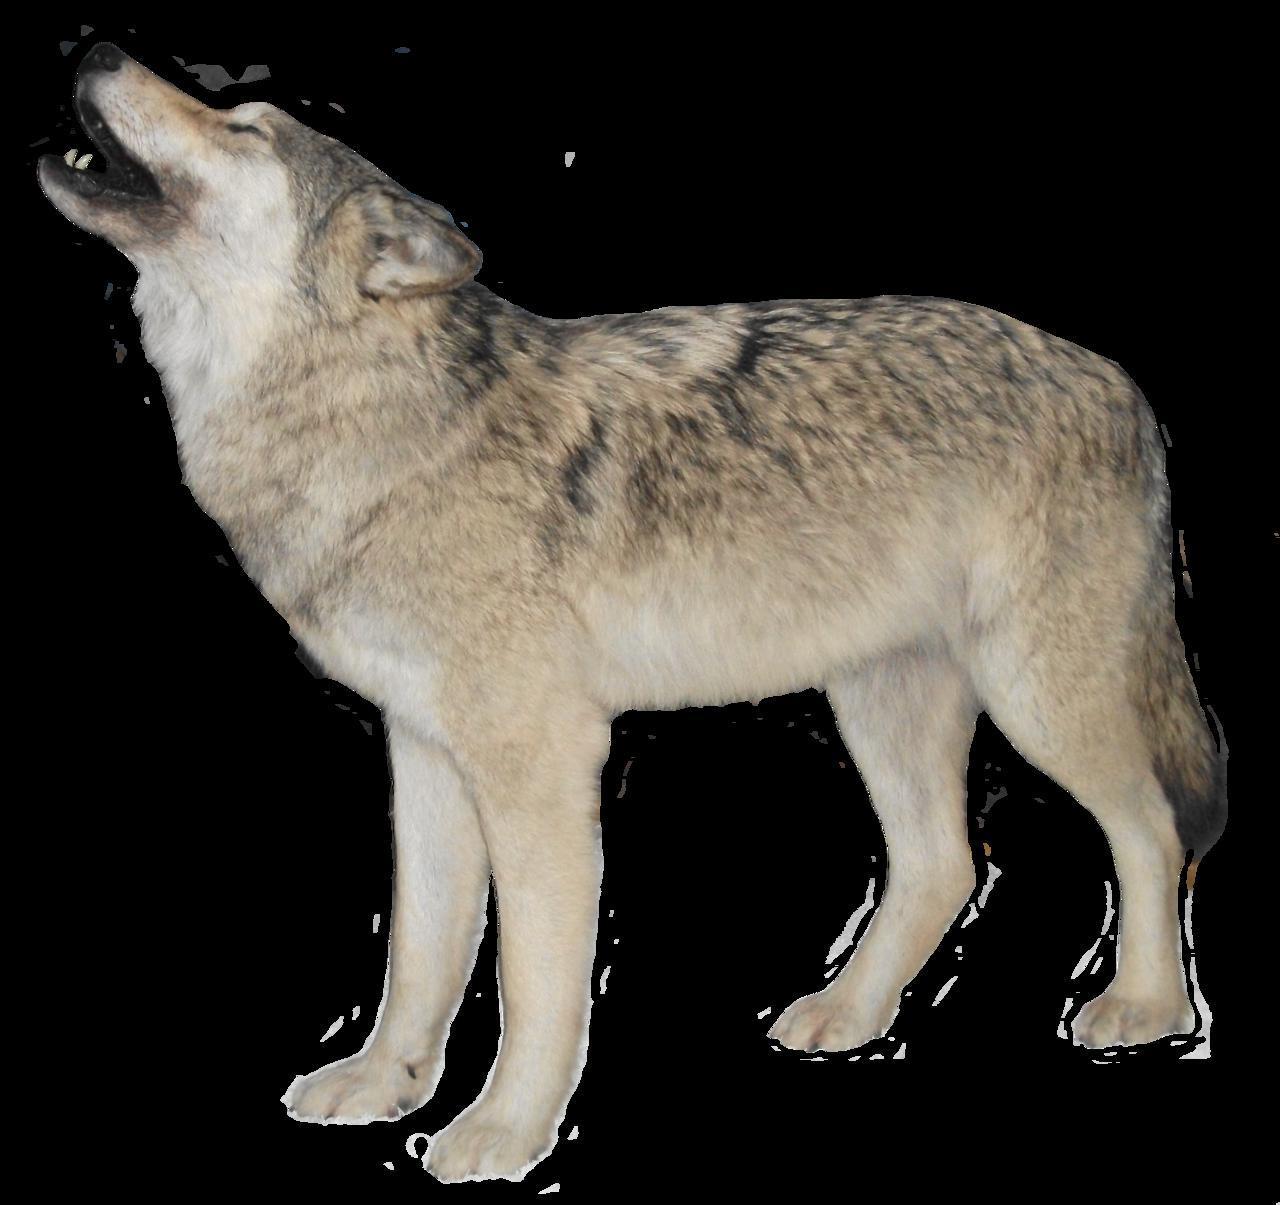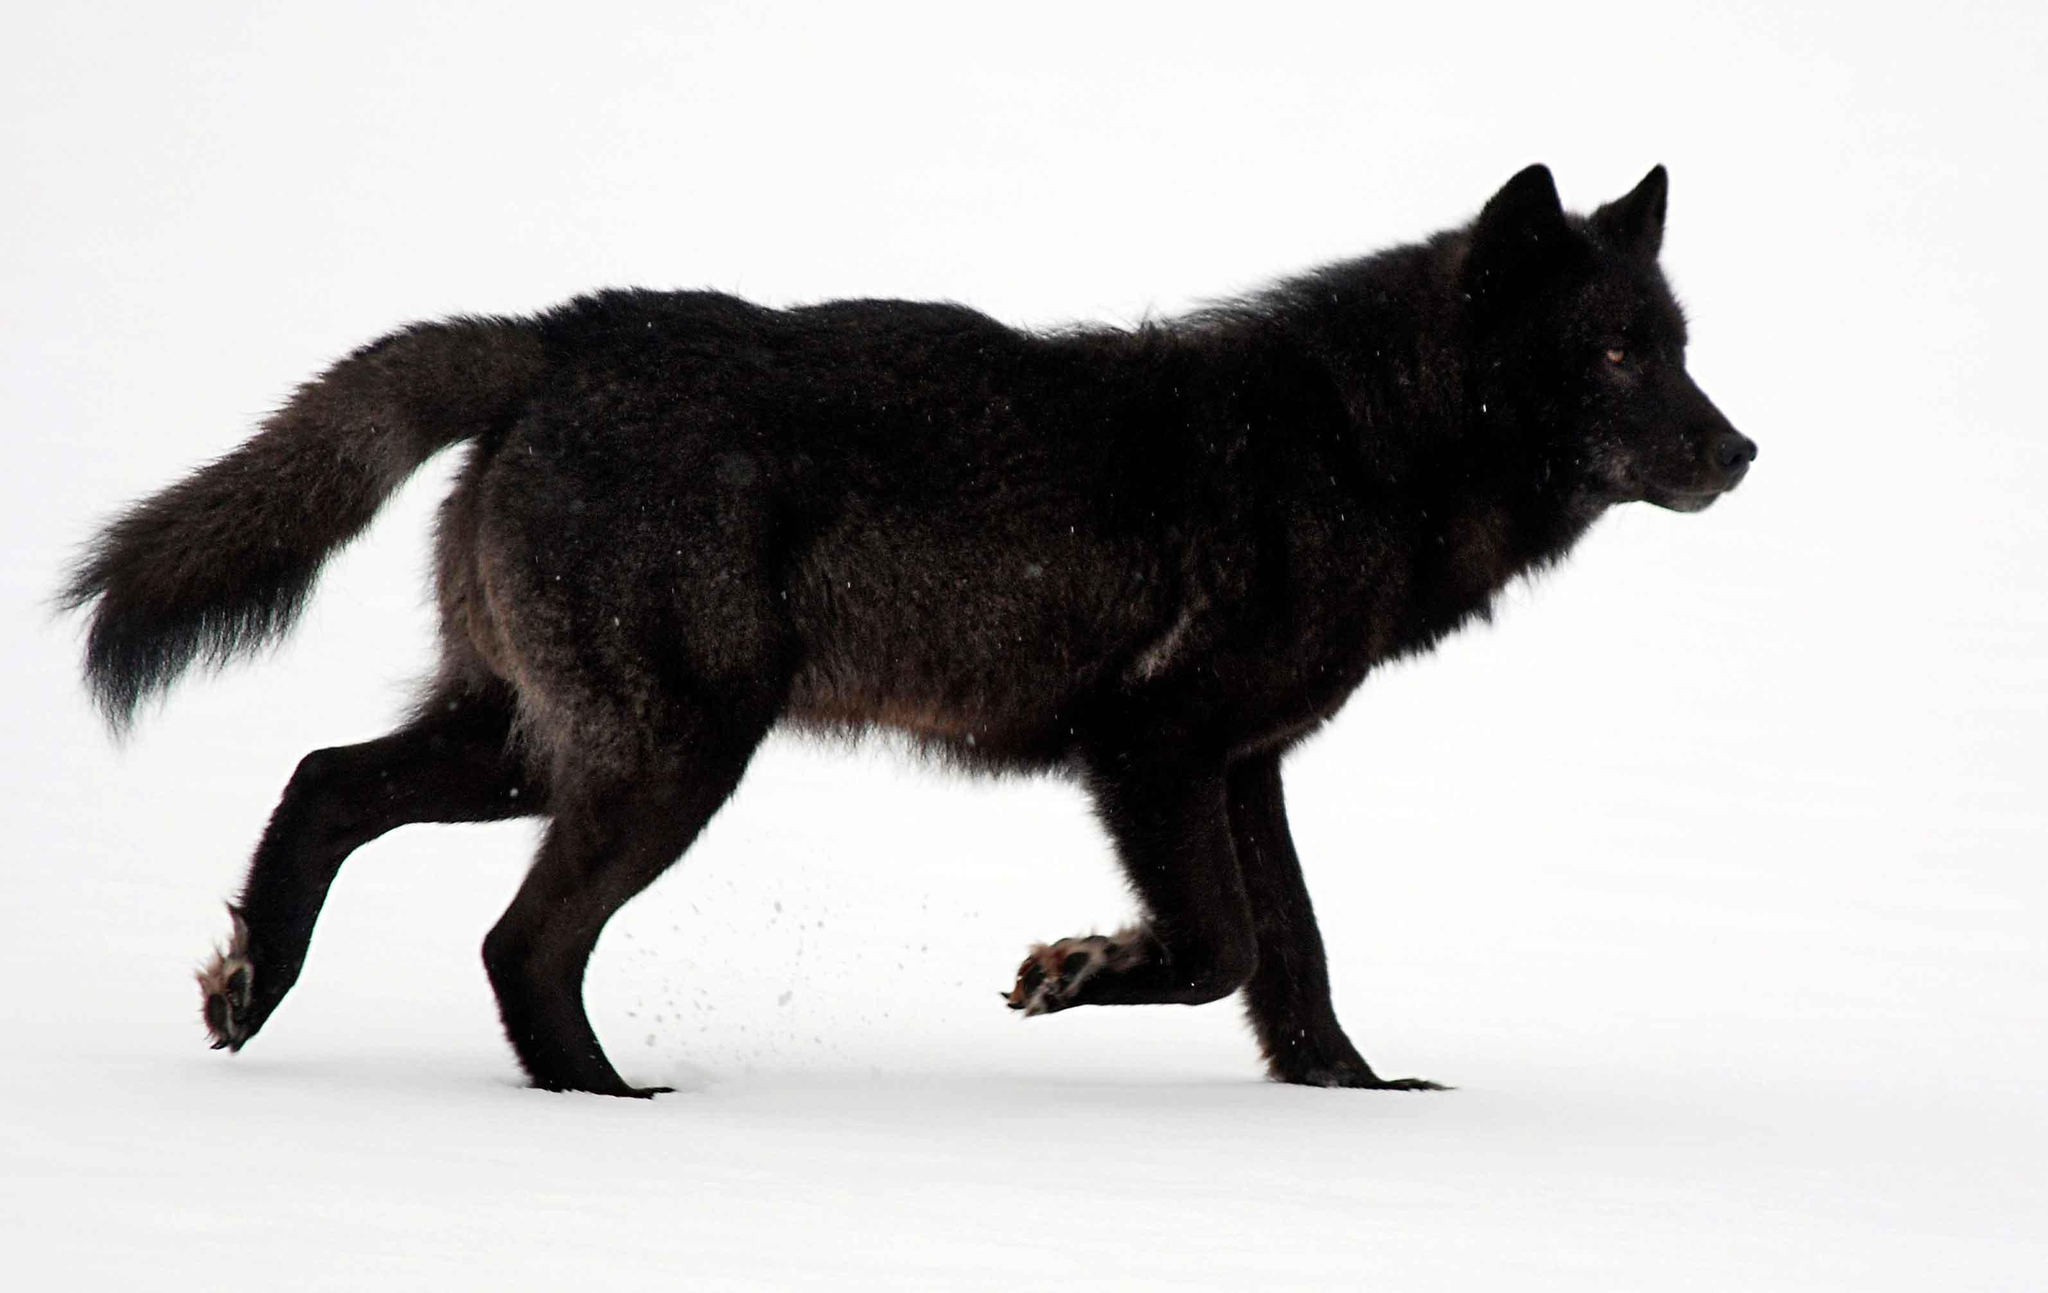The first image is the image on the left, the second image is the image on the right. Given the left and right images, does the statement "One image shows a howling wolf with raised head." hold true? Answer yes or no. Yes. 